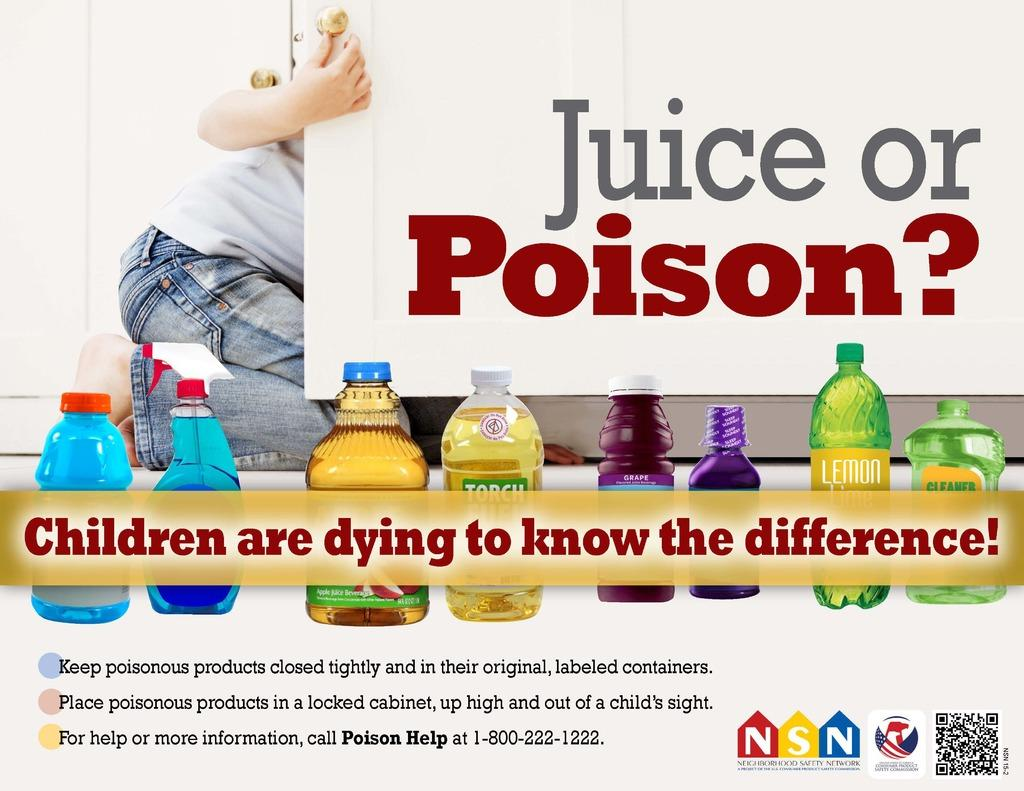<image>
Summarize the visual content of the image. An advertisement for child safety about keeping poisonous products closed tightly. 